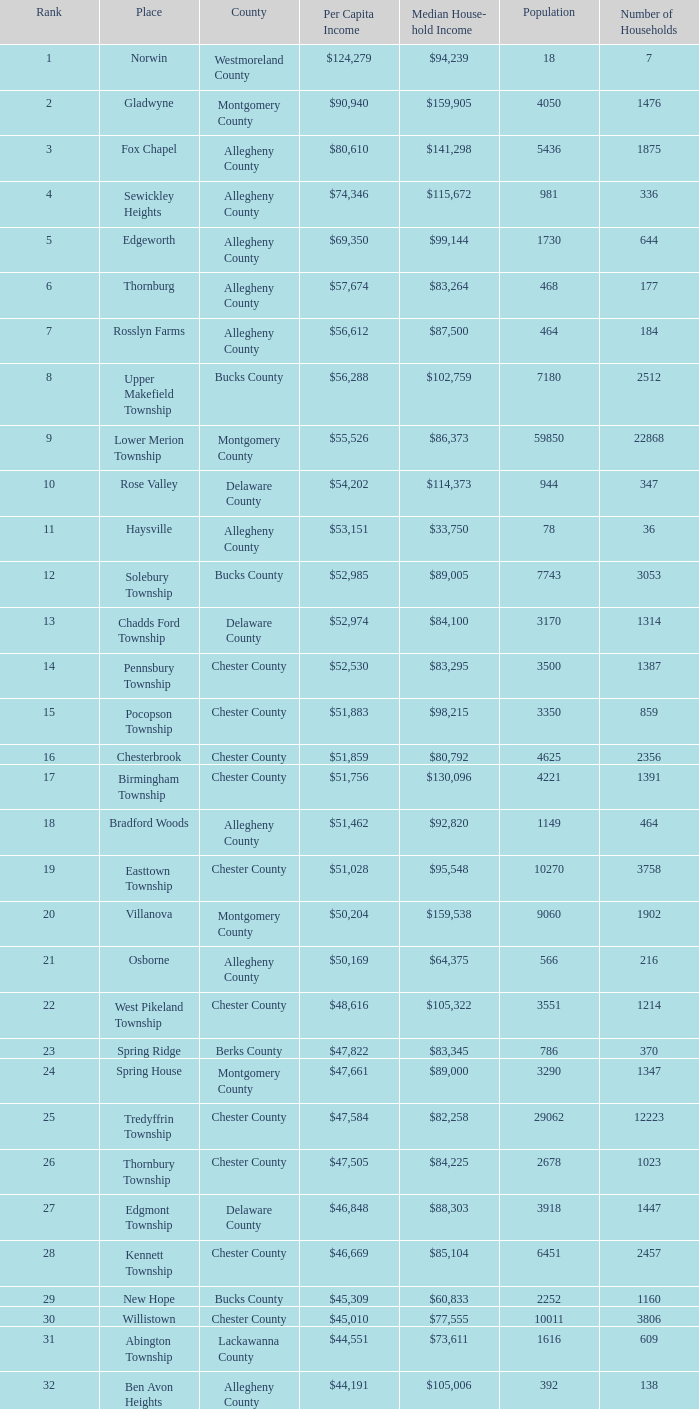What county has 2053 households?  Chester County. 